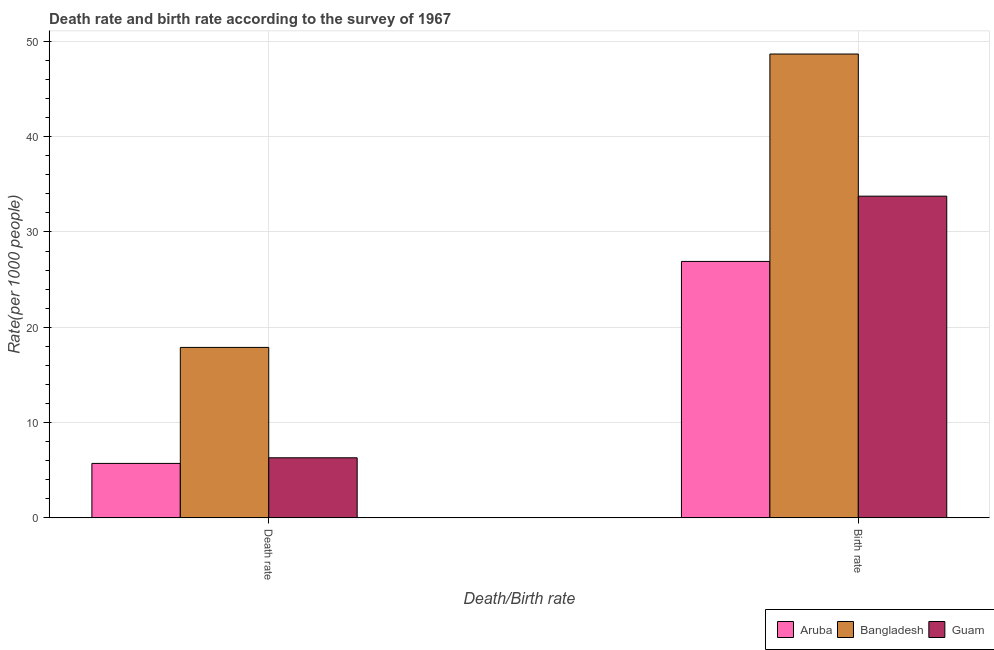How many different coloured bars are there?
Your response must be concise. 3. Are the number of bars per tick equal to the number of legend labels?
Ensure brevity in your answer.  Yes. How many bars are there on the 1st tick from the left?
Your answer should be very brief. 3. What is the label of the 1st group of bars from the left?
Your answer should be very brief. Death rate. What is the death rate in Aruba?
Ensure brevity in your answer.  5.72. Across all countries, what is the maximum death rate?
Your answer should be compact. 17.89. Across all countries, what is the minimum death rate?
Provide a short and direct response. 5.72. In which country was the birth rate minimum?
Ensure brevity in your answer.  Aruba. What is the total death rate in the graph?
Your response must be concise. 29.91. What is the difference between the death rate in Aruba and that in Bangladesh?
Offer a very short reply. -12.17. What is the difference between the birth rate in Aruba and the death rate in Guam?
Your response must be concise. 20.6. What is the average death rate per country?
Your response must be concise. 9.97. What is the difference between the death rate and birth rate in Bangladesh?
Your answer should be compact. -30.78. What is the ratio of the death rate in Aruba to that in Bangladesh?
Provide a succinct answer. 0.32. In how many countries, is the birth rate greater than the average birth rate taken over all countries?
Make the answer very short. 1. What does the 1st bar from the left in Birth rate represents?
Keep it short and to the point. Aruba. What does the 2nd bar from the right in Birth rate represents?
Ensure brevity in your answer.  Bangladesh. How many bars are there?
Ensure brevity in your answer.  6. How many countries are there in the graph?
Your answer should be very brief. 3. What is the difference between two consecutive major ticks on the Y-axis?
Give a very brief answer. 10. Are the values on the major ticks of Y-axis written in scientific E-notation?
Ensure brevity in your answer.  No. Does the graph contain any zero values?
Keep it short and to the point. No. Does the graph contain grids?
Your answer should be compact. Yes. What is the title of the graph?
Make the answer very short. Death rate and birth rate according to the survey of 1967. What is the label or title of the X-axis?
Your response must be concise. Death/Birth rate. What is the label or title of the Y-axis?
Offer a very short reply. Rate(per 1000 people). What is the Rate(per 1000 people) in Aruba in Death rate?
Offer a terse response. 5.72. What is the Rate(per 1000 people) of Bangladesh in Death rate?
Provide a succinct answer. 17.89. What is the Rate(per 1000 people) in Guam in Death rate?
Give a very brief answer. 6.31. What is the Rate(per 1000 people) of Aruba in Birth rate?
Make the answer very short. 26.91. What is the Rate(per 1000 people) in Bangladesh in Birth rate?
Give a very brief answer. 48.67. What is the Rate(per 1000 people) of Guam in Birth rate?
Offer a very short reply. 33.75. Across all Death/Birth rate, what is the maximum Rate(per 1000 people) of Aruba?
Your answer should be compact. 26.91. Across all Death/Birth rate, what is the maximum Rate(per 1000 people) in Bangladesh?
Keep it short and to the point. 48.67. Across all Death/Birth rate, what is the maximum Rate(per 1000 people) in Guam?
Your answer should be very brief. 33.75. Across all Death/Birth rate, what is the minimum Rate(per 1000 people) in Aruba?
Offer a very short reply. 5.72. Across all Death/Birth rate, what is the minimum Rate(per 1000 people) of Bangladesh?
Offer a terse response. 17.89. Across all Death/Birth rate, what is the minimum Rate(per 1000 people) in Guam?
Offer a very short reply. 6.31. What is the total Rate(per 1000 people) of Aruba in the graph?
Give a very brief answer. 32.62. What is the total Rate(per 1000 people) in Bangladesh in the graph?
Give a very brief answer. 66.55. What is the total Rate(per 1000 people) in Guam in the graph?
Your answer should be very brief. 40.06. What is the difference between the Rate(per 1000 people) in Aruba in Death rate and that in Birth rate?
Provide a short and direct response. -21.19. What is the difference between the Rate(per 1000 people) of Bangladesh in Death rate and that in Birth rate?
Offer a terse response. -30.78. What is the difference between the Rate(per 1000 people) in Guam in Death rate and that in Birth rate?
Give a very brief answer. -27.45. What is the difference between the Rate(per 1000 people) in Aruba in Death rate and the Rate(per 1000 people) in Bangladesh in Birth rate?
Offer a terse response. -42.95. What is the difference between the Rate(per 1000 people) of Aruba in Death rate and the Rate(per 1000 people) of Guam in Birth rate?
Provide a succinct answer. -28.04. What is the difference between the Rate(per 1000 people) of Bangladesh in Death rate and the Rate(per 1000 people) of Guam in Birth rate?
Offer a terse response. -15.87. What is the average Rate(per 1000 people) of Aruba per Death/Birth rate?
Make the answer very short. 16.31. What is the average Rate(per 1000 people) of Bangladesh per Death/Birth rate?
Provide a short and direct response. 33.28. What is the average Rate(per 1000 people) in Guam per Death/Birth rate?
Offer a very short reply. 20.03. What is the difference between the Rate(per 1000 people) in Aruba and Rate(per 1000 people) in Bangladesh in Death rate?
Offer a very short reply. -12.17. What is the difference between the Rate(per 1000 people) of Aruba and Rate(per 1000 people) of Guam in Death rate?
Provide a short and direct response. -0.59. What is the difference between the Rate(per 1000 people) in Bangladesh and Rate(per 1000 people) in Guam in Death rate?
Give a very brief answer. 11.58. What is the difference between the Rate(per 1000 people) in Aruba and Rate(per 1000 people) in Bangladesh in Birth rate?
Offer a very short reply. -21.76. What is the difference between the Rate(per 1000 people) in Aruba and Rate(per 1000 people) in Guam in Birth rate?
Make the answer very short. -6.85. What is the difference between the Rate(per 1000 people) of Bangladesh and Rate(per 1000 people) of Guam in Birth rate?
Offer a terse response. 14.91. What is the ratio of the Rate(per 1000 people) in Aruba in Death rate to that in Birth rate?
Offer a very short reply. 0.21. What is the ratio of the Rate(per 1000 people) of Bangladesh in Death rate to that in Birth rate?
Provide a succinct answer. 0.37. What is the ratio of the Rate(per 1000 people) in Guam in Death rate to that in Birth rate?
Provide a succinct answer. 0.19. What is the difference between the highest and the second highest Rate(per 1000 people) of Aruba?
Your response must be concise. 21.19. What is the difference between the highest and the second highest Rate(per 1000 people) in Bangladesh?
Provide a short and direct response. 30.78. What is the difference between the highest and the second highest Rate(per 1000 people) of Guam?
Make the answer very short. 27.45. What is the difference between the highest and the lowest Rate(per 1000 people) in Aruba?
Provide a short and direct response. 21.19. What is the difference between the highest and the lowest Rate(per 1000 people) of Bangladesh?
Give a very brief answer. 30.78. What is the difference between the highest and the lowest Rate(per 1000 people) of Guam?
Keep it short and to the point. 27.45. 